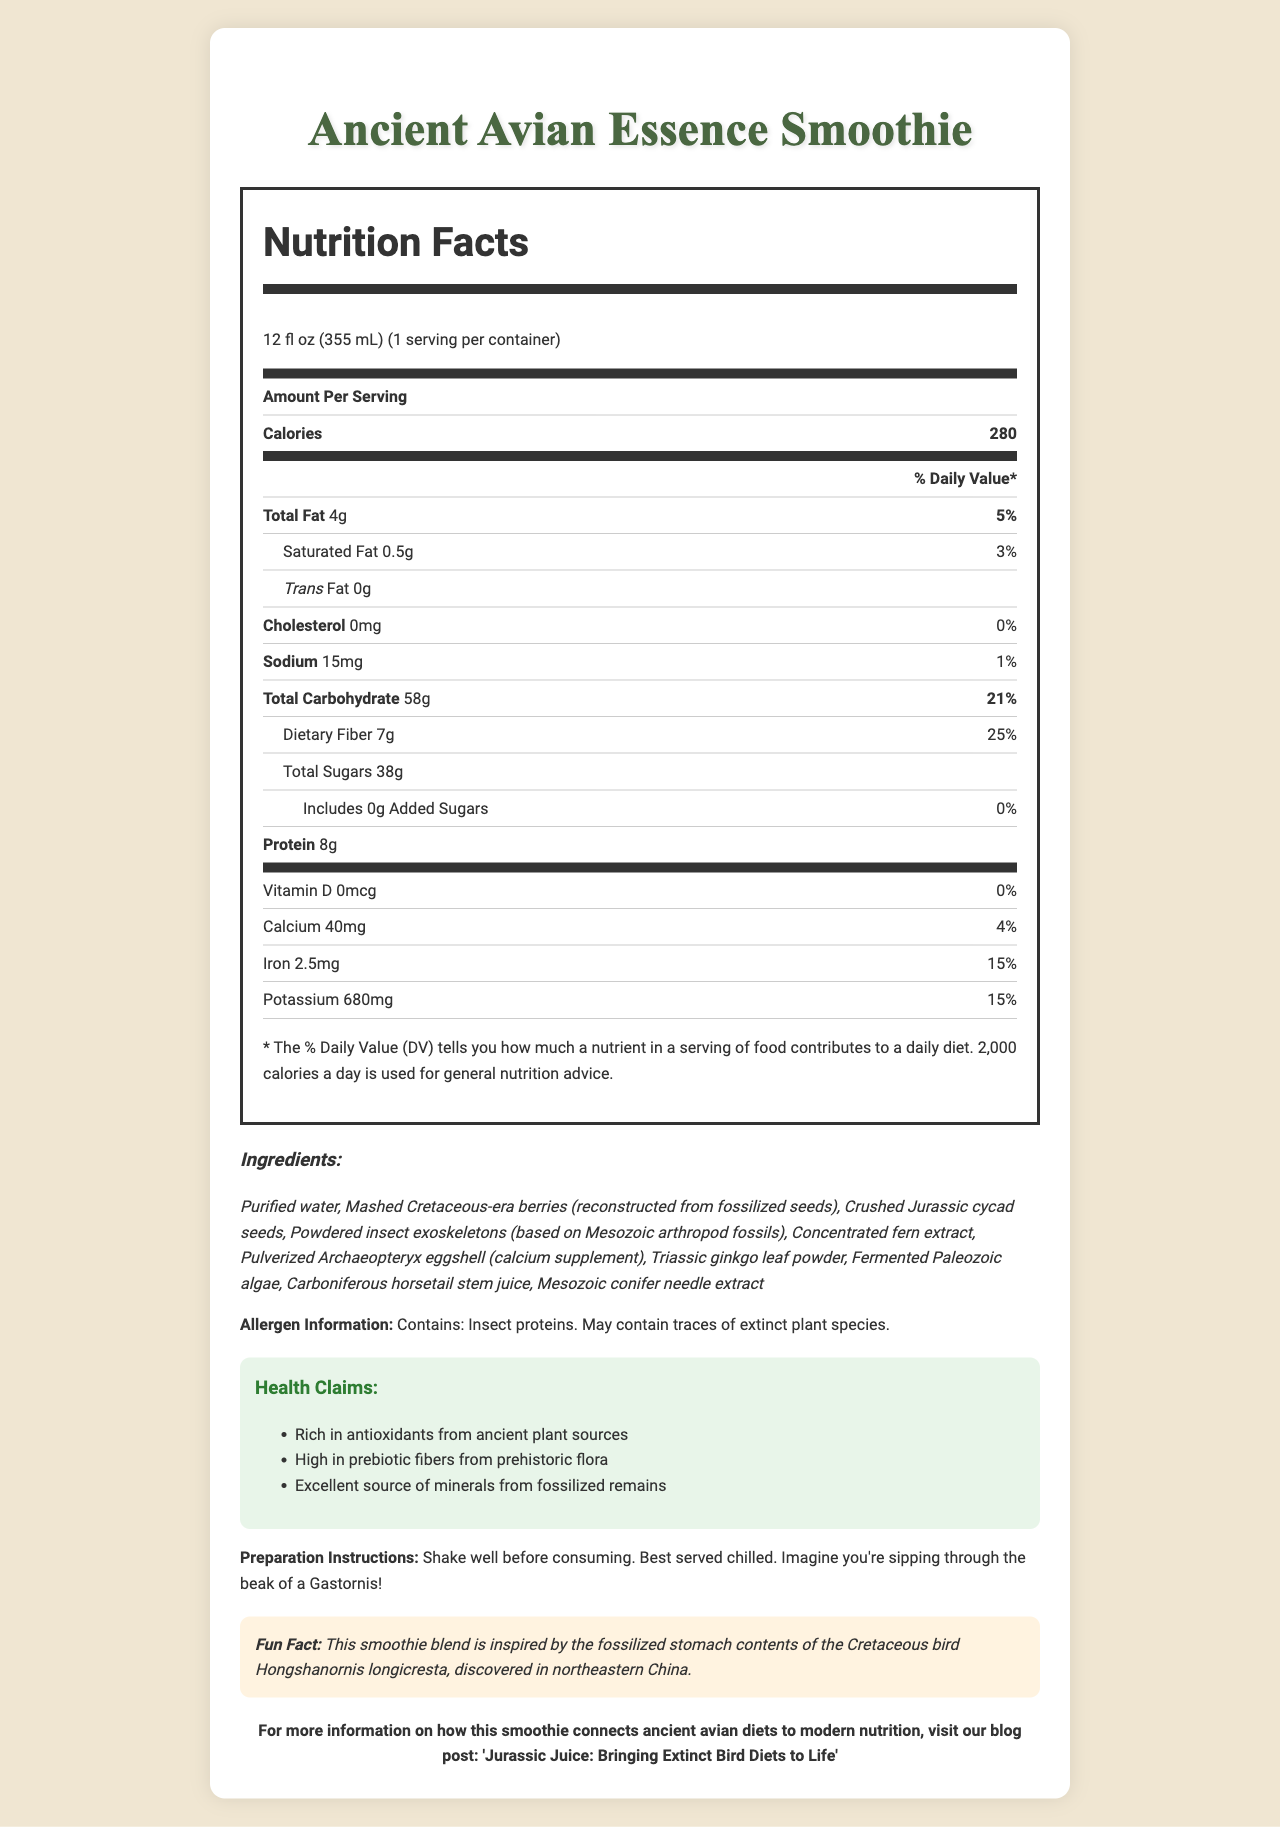what is the serving size for the Ancient Avian Essence Smoothie? The serving size is explicitly stated in the document as 12 fl oz (355 mL).
Answer: 12 fl oz (355 mL) How many calories are in one serving of the Ancient Avian Essence Smoothie? The document lists the calories per serving as 280.
Answer: 280 calories What is the amount of protein in the Ancient Avian Essence Smoothie? The document specifies that the smoothie contains 8 grams of protein per serving.
Answer: 8g What is the major source of antioxidants in the Ancient Avian Essence Smoothie? The health claims section mentions that the smoothie is rich in antioxidants from ancient plant sources.
Answer: Ancient plant sources How much dietary fiber does the Ancient Avian Essence Smoothie provide? According to the nutrition facts label, the smoothie provides 7 grams of dietary fiber per serving.
Answer: 7g Which of the following ingredients is not included in the Ancient Avian Essence Smoothie? A. Crushed Jurassic cycad seeds B. Fermented Paleozoic algae C. Modern fruits The listed ingredients include Crushed Jurassic cycad seeds and Fermented Paleozoic algae, but no modern fruits are mentioned.
Answer: C. Modern fruits What percentage of the daily value for iron does the Ancient Avian Essence Smoothie provide? A. 10% B. 15% C. 25% D. 50% The nutrition facts label shows that the smoothie provides 15% of the daily value for iron.
Answer: B. 15% Is there any cholesterol in the Ancient Avian Essence Smoothie? Yes/No The nutrition facts indicate the cholesterol amount as 0mg, meaning there is no cholesterol in the smoothie.
Answer: No Summarize the purpose and key details of the Ancient Avian Essence Smoothie document. The document covers various aspects of the Ancient Avian Essence Smoothie in detail, outlining its nutritional facts, unique ingredients mimicking ancient diets, health benefits, allergen information, and instructions for preparation, along with a fun historical tidbit and a link to a related blog post.
Answer: The document provides comprehensive information about the Ancient Avian Essence Smoothie, including its nutritional content, ingredients, health claims, allergen information, preparation instructions, and a fun fact. The smoothie replicates the diet of extinct bird species based on fossil evidence and aims to deliver health benefits by incorporating ancient plant sources. What was the inspiration for the Ancient Avian Essence Smoothie? The fun fact section reveals that the smoothie is inspired by the fossilized stomach contents of this particular bird species.
Answer: The fossilized stomach contents of the Cretaceous bird Hongshanornis longicresta What is the % Daily Value of potassium provided by the Ancient Avian Essence Smoothie? The nutrition facts label states that the smoothie provides 15% of the daily value for potassium.
Answer: 15% Can we tell from the document how much Vitamin C is in the smoothie? The document does not provide any data regarding the Vitamin C content in the smoothie.
Answer: Not enough information 